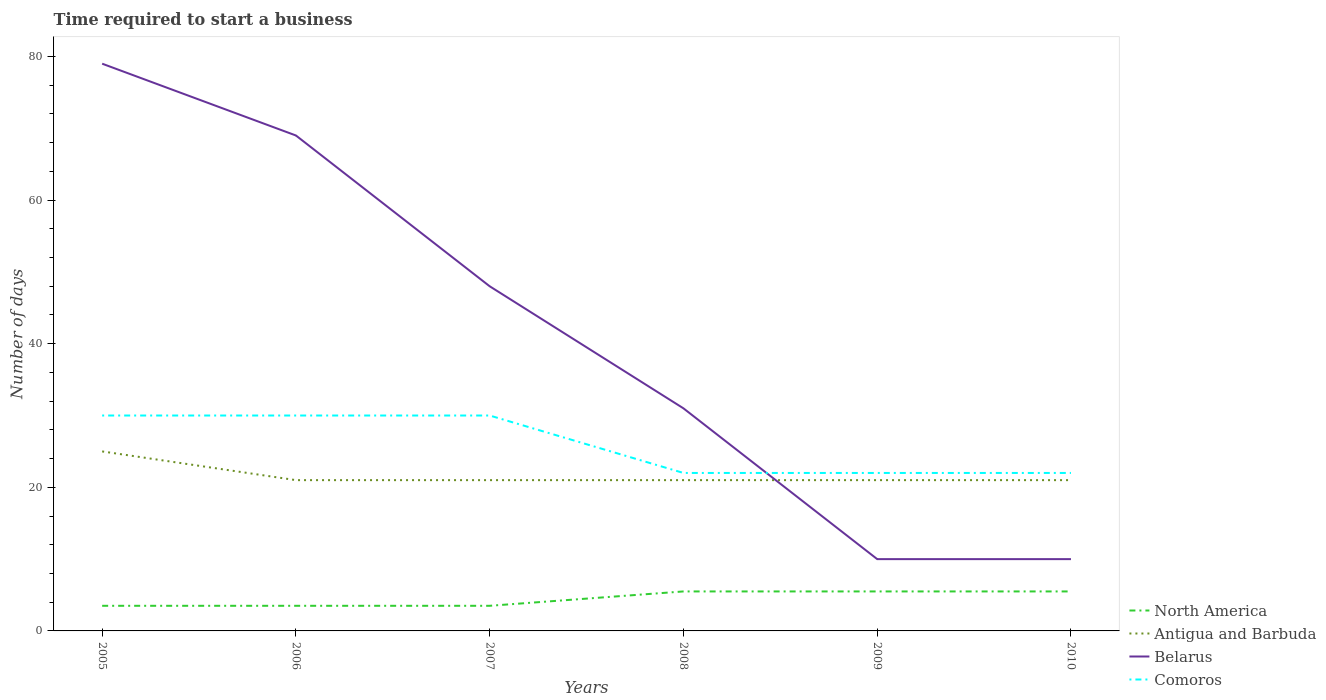Does the line corresponding to Comoros intersect with the line corresponding to North America?
Your answer should be compact. No. Is the number of lines equal to the number of legend labels?
Give a very brief answer. Yes. Across all years, what is the maximum number of days required to start a business in Antigua and Barbuda?
Your answer should be compact. 21. In which year was the number of days required to start a business in Antigua and Barbuda maximum?
Make the answer very short. 2006. What is the difference between the highest and the second highest number of days required to start a business in Antigua and Barbuda?
Give a very brief answer. 4. How many years are there in the graph?
Provide a short and direct response. 6. What is the difference between two consecutive major ticks on the Y-axis?
Provide a succinct answer. 20. Where does the legend appear in the graph?
Give a very brief answer. Bottom right. How many legend labels are there?
Your answer should be compact. 4. What is the title of the graph?
Ensure brevity in your answer.  Time required to start a business. Does "Syrian Arab Republic" appear as one of the legend labels in the graph?
Your answer should be compact. No. What is the label or title of the X-axis?
Provide a short and direct response. Years. What is the label or title of the Y-axis?
Keep it short and to the point. Number of days. What is the Number of days in Antigua and Barbuda in 2005?
Provide a short and direct response. 25. What is the Number of days in Belarus in 2005?
Give a very brief answer. 79. What is the Number of days in North America in 2006?
Offer a terse response. 3.5. What is the Number of days in Comoros in 2006?
Provide a short and direct response. 30. What is the Number of days of North America in 2007?
Your answer should be compact. 3.5. What is the Number of days of Antigua and Barbuda in 2007?
Offer a terse response. 21. What is the Number of days in Belarus in 2007?
Offer a terse response. 48. What is the Number of days in Comoros in 2007?
Ensure brevity in your answer.  30. What is the Number of days in Belarus in 2008?
Provide a short and direct response. 31. What is the Number of days of North America in 2009?
Offer a very short reply. 5.5. What is the Number of days in North America in 2010?
Offer a very short reply. 5.5. What is the Number of days of Antigua and Barbuda in 2010?
Provide a short and direct response. 21. What is the Number of days in Belarus in 2010?
Your response must be concise. 10. What is the Number of days in Comoros in 2010?
Provide a short and direct response. 22. Across all years, what is the maximum Number of days of North America?
Offer a terse response. 5.5. Across all years, what is the maximum Number of days in Antigua and Barbuda?
Keep it short and to the point. 25. Across all years, what is the maximum Number of days of Belarus?
Give a very brief answer. 79. Across all years, what is the maximum Number of days in Comoros?
Your answer should be very brief. 30. Across all years, what is the minimum Number of days of Comoros?
Give a very brief answer. 22. What is the total Number of days in North America in the graph?
Keep it short and to the point. 27. What is the total Number of days of Antigua and Barbuda in the graph?
Your answer should be compact. 130. What is the total Number of days of Belarus in the graph?
Keep it short and to the point. 247. What is the total Number of days of Comoros in the graph?
Give a very brief answer. 156. What is the difference between the Number of days in Belarus in 2005 and that in 2006?
Provide a succinct answer. 10. What is the difference between the Number of days in Comoros in 2005 and that in 2007?
Your answer should be very brief. 0. What is the difference between the Number of days of North America in 2005 and that in 2008?
Keep it short and to the point. -2. What is the difference between the Number of days of Antigua and Barbuda in 2005 and that in 2008?
Offer a terse response. 4. What is the difference between the Number of days in Comoros in 2005 and that in 2009?
Offer a terse response. 8. What is the difference between the Number of days in North America in 2005 and that in 2010?
Your response must be concise. -2. What is the difference between the Number of days in Antigua and Barbuda in 2005 and that in 2010?
Your answer should be compact. 4. What is the difference between the Number of days in Belarus in 2005 and that in 2010?
Provide a succinct answer. 69. What is the difference between the Number of days in North America in 2006 and that in 2007?
Give a very brief answer. 0. What is the difference between the Number of days in Antigua and Barbuda in 2006 and that in 2007?
Make the answer very short. 0. What is the difference between the Number of days of Comoros in 2006 and that in 2007?
Your answer should be very brief. 0. What is the difference between the Number of days in North America in 2006 and that in 2008?
Ensure brevity in your answer.  -2. What is the difference between the Number of days in Antigua and Barbuda in 2006 and that in 2009?
Ensure brevity in your answer.  0. What is the difference between the Number of days in Belarus in 2006 and that in 2009?
Keep it short and to the point. 59. What is the difference between the Number of days in Comoros in 2006 and that in 2009?
Provide a short and direct response. 8. What is the difference between the Number of days of Belarus in 2006 and that in 2010?
Ensure brevity in your answer.  59. What is the difference between the Number of days of Comoros in 2006 and that in 2010?
Ensure brevity in your answer.  8. What is the difference between the Number of days in Antigua and Barbuda in 2007 and that in 2008?
Keep it short and to the point. 0. What is the difference between the Number of days in Belarus in 2007 and that in 2008?
Provide a succinct answer. 17. What is the difference between the Number of days of North America in 2007 and that in 2009?
Provide a short and direct response. -2. What is the difference between the Number of days in Antigua and Barbuda in 2007 and that in 2009?
Give a very brief answer. 0. What is the difference between the Number of days of Belarus in 2007 and that in 2009?
Provide a short and direct response. 38. What is the difference between the Number of days of Comoros in 2007 and that in 2009?
Make the answer very short. 8. What is the difference between the Number of days of North America in 2008 and that in 2009?
Ensure brevity in your answer.  0. What is the difference between the Number of days of Belarus in 2008 and that in 2009?
Offer a very short reply. 21. What is the difference between the Number of days in Comoros in 2008 and that in 2009?
Keep it short and to the point. 0. What is the difference between the Number of days of North America in 2008 and that in 2010?
Your response must be concise. 0. What is the difference between the Number of days of North America in 2009 and that in 2010?
Provide a succinct answer. 0. What is the difference between the Number of days in Belarus in 2009 and that in 2010?
Keep it short and to the point. 0. What is the difference between the Number of days in North America in 2005 and the Number of days in Antigua and Barbuda in 2006?
Keep it short and to the point. -17.5. What is the difference between the Number of days in North America in 2005 and the Number of days in Belarus in 2006?
Your answer should be very brief. -65.5. What is the difference between the Number of days of North America in 2005 and the Number of days of Comoros in 2006?
Keep it short and to the point. -26.5. What is the difference between the Number of days in Antigua and Barbuda in 2005 and the Number of days in Belarus in 2006?
Provide a succinct answer. -44. What is the difference between the Number of days in North America in 2005 and the Number of days in Antigua and Barbuda in 2007?
Offer a very short reply. -17.5. What is the difference between the Number of days in North America in 2005 and the Number of days in Belarus in 2007?
Give a very brief answer. -44.5. What is the difference between the Number of days in North America in 2005 and the Number of days in Comoros in 2007?
Keep it short and to the point. -26.5. What is the difference between the Number of days in Antigua and Barbuda in 2005 and the Number of days in Belarus in 2007?
Provide a short and direct response. -23. What is the difference between the Number of days of Antigua and Barbuda in 2005 and the Number of days of Comoros in 2007?
Offer a very short reply. -5. What is the difference between the Number of days of Belarus in 2005 and the Number of days of Comoros in 2007?
Give a very brief answer. 49. What is the difference between the Number of days of North America in 2005 and the Number of days of Antigua and Barbuda in 2008?
Make the answer very short. -17.5. What is the difference between the Number of days in North America in 2005 and the Number of days in Belarus in 2008?
Ensure brevity in your answer.  -27.5. What is the difference between the Number of days in North America in 2005 and the Number of days in Comoros in 2008?
Give a very brief answer. -18.5. What is the difference between the Number of days of Antigua and Barbuda in 2005 and the Number of days of Comoros in 2008?
Your answer should be very brief. 3. What is the difference between the Number of days in Belarus in 2005 and the Number of days in Comoros in 2008?
Provide a succinct answer. 57. What is the difference between the Number of days of North America in 2005 and the Number of days of Antigua and Barbuda in 2009?
Your answer should be very brief. -17.5. What is the difference between the Number of days of North America in 2005 and the Number of days of Comoros in 2009?
Offer a very short reply. -18.5. What is the difference between the Number of days of North America in 2005 and the Number of days of Antigua and Barbuda in 2010?
Offer a very short reply. -17.5. What is the difference between the Number of days in North America in 2005 and the Number of days in Belarus in 2010?
Provide a succinct answer. -6.5. What is the difference between the Number of days of North America in 2005 and the Number of days of Comoros in 2010?
Provide a succinct answer. -18.5. What is the difference between the Number of days in Antigua and Barbuda in 2005 and the Number of days in Belarus in 2010?
Your response must be concise. 15. What is the difference between the Number of days of Antigua and Barbuda in 2005 and the Number of days of Comoros in 2010?
Give a very brief answer. 3. What is the difference between the Number of days of Belarus in 2005 and the Number of days of Comoros in 2010?
Provide a succinct answer. 57. What is the difference between the Number of days in North America in 2006 and the Number of days in Antigua and Barbuda in 2007?
Your answer should be compact. -17.5. What is the difference between the Number of days of North America in 2006 and the Number of days of Belarus in 2007?
Make the answer very short. -44.5. What is the difference between the Number of days of North America in 2006 and the Number of days of Comoros in 2007?
Provide a succinct answer. -26.5. What is the difference between the Number of days in North America in 2006 and the Number of days in Antigua and Barbuda in 2008?
Make the answer very short. -17.5. What is the difference between the Number of days in North America in 2006 and the Number of days in Belarus in 2008?
Give a very brief answer. -27.5. What is the difference between the Number of days of North America in 2006 and the Number of days of Comoros in 2008?
Keep it short and to the point. -18.5. What is the difference between the Number of days in Antigua and Barbuda in 2006 and the Number of days in Comoros in 2008?
Your answer should be compact. -1. What is the difference between the Number of days in Belarus in 2006 and the Number of days in Comoros in 2008?
Your answer should be very brief. 47. What is the difference between the Number of days in North America in 2006 and the Number of days in Antigua and Barbuda in 2009?
Keep it short and to the point. -17.5. What is the difference between the Number of days in North America in 2006 and the Number of days in Comoros in 2009?
Offer a very short reply. -18.5. What is the difference between the Number of days of Antigua and Barbuda in 2006 and the Number of days of Belarus in 2009?
Offer a very short reply. 11. What is the difference between the Number of days of Antigua and Barbuda in 2006 and the Number of days of Comoros in 2009?
Make the answer very short. -1. What is the difference between the Number of days in North America in 2006 and the Number of days in Antigua and Barbuda in 2010?
Keep it short and to the point. -17.5. What is the difference between the Number of days of North America in 2006 and the Number of days of Comoros in 2010?
Your answer should be very brief. -18.5. What is the difference between the Number of days in North America in 2007 and the Number of days in Antigua and Barbuda in 2008?
Make the answer very short. -17.5. What is the difference between the Number of days in North America in 2007 and the Number of days in Belarus in 2008?
Provide a short and direct response. -27.5. What is the difference between the Number of days in North America in 2007 and the Number of days in Comoros in 2008?
Ensure brevity in your answer.  -18.5. What is the difference between the Number of days in Antigua and Barbuda in 2007 and the Number of days in Belarus in 2008?
Offer a very short reply. -10. What is the difference between the Number of days in Belarus in 2007 and the Number of days in Comoros in 2008?
Your answer should be compact. 26. What is the difference between the Number of days of North America in 2007 and the Number of days of Antigua and Barbuda in 2009?
Offer a terse response. -17.5. What is the difference between the Number of days in North America in 2007 and the Number of days in Belarus in 2009?
Your response must be concise. -6.5. What is the difference between the Number of days in North America in 2007 and the Number of days in Comoros in 2009?
Offer a very short reply. -18.5. What is the difference between the Number of days of Antigua and Barbuda in 2007 and the Number of days of Belarus in 2009?
Ensure brevity in your answer.  11. What is the difference between the Number of days in North America in 2007 and the Number of days in Antigua and Barbuda in 2010?
Ensure brevity in your answer.  -17.5. What is the difference between the Number of days in North America in 2007 and the Number of days in Belarus in 2010?
Provide a short and direct response. -6.5. What is the difference between the Number of days of North America in 2007 and the Number of days of Comoros in 2010?
Offer a very short reply. -18.5. What is the difference between the Number of days in Antigua and Barbuda in 2007 and the Number of days in Belarus in 2010?
Offer a very short reply. 11. What is the difference between the Number of days of Antigua and Barbuda in 2007 and the Number of days of Comoros in 2010?
Your response must be concise. -1. What is the difference between the Number of days of North America in 2008 and the Number of days of Antigua and Barbuda in 2009?
Provide a short and direct response. -15.5. What is the difference between the Number of days of North America in 2008 and the Number of days of Comoros in 2009?
Offer a terse response. -16.5. What is the difference between the Number of days in Antigua and Barbuda in 2008 and the Number of days in Belarus in 2009?
Provide a succinct answer. 11. What is the difference between the Number of days in Belarus in 2008 and the Number of days in Comoros in 2009?
Offer a terse response. 9. What is the difference between the Number of days of North America in 2008 and the Number of days of Antigua and Barbuda in 2010?
Provide a succinct answer. -15.5. What is the difference between the Number of days of North America in 2008 and the Number of days of Comoros in 2010?
Give a very brief answer. -16.5. What is the difference between the Number of days of Antigua and Barbuda in 2008 and the Number of days of Comoros in 2010?
Give a very brief answer. -1. What is the difference between the Number of days of North America in 2009 and the Number of days of Antigua and Barbuda in 2010?
Ensure brevity in your answer.  -15.5. What is the difference between the Number of days of North America in 2009 and the Number of days of Belarus in 2010?
Provide a short and direct response. -4.5. What is the difference between the Number of days in North America in 2009 and the Number of days in Comoros in 2010?
Your answer should be very brief. -16.5. What is the difference between the Number of days in Antigua and Barbuda in 2009 and the Number of days in Belarus in 2010?
Your answer should be compact. 11. What is the average Number of days of North America per year?
Give a very brief answer. 4.5. What is the average Number of days of Antigua and Barbuda per year?
Your answer should be very brief. 21.67. What is the average Number of days in Belarus per year?
Your answer should be compact. 41.17. What is the average Number of days in Comoros per year?
Keep it short and to the point. 26. In the year 2005, what is the difference between the Number of days of North America and Number of days of Antigua and Barbuda?
Offer a terse response. -21.5. In the year 2005, what is the difference between the Number of days in North America and Number of days in Belarus?
Give a very brief answer. -75.5. In the year 2005, what is the difference between the Number of days of North America and Number of days of Comoros?
Ensure brevity in your answer.  -26.5. In the year 2005, what is the difference between the Number of days of Antigua and Barbuda and Number of days of Belarus?
Give a very brief answer. -54. In the year 2005, what is the difference between the Number of days of Belarus and Number of days of Comoros?
Ensure brevity in your answer.  49. In the year 2006, what is the difference between the Number of days in North America and Number of days in Antigua and Barbuda?
Your answer should be very brief. -17.5. In the year 2006, what is the difference between the Number of days of North America and Number of days of Belarus?
Give a very brief answer. -65.5. In the year 2006, what is the difference between the Number of days of North America and Number of days of Comoros?
Make the answer very short. -26.5. In the year 2006, what is the difference between the Number of days in Antigua and Barbuda and Number of days in Belarus?
Keep it short and to the point. -48. In the year 2006, what is the difference between the Number of days of Antigua and Barbuda and Number of days of Comoros?
Provide a succinct answer. -9. In the year 2007, what is the difference between the Number of days of North America and Number of days of Antigua and Barbuda?
Provide a succinct answer. -17.5. In the year 2007, what is the difference between the Number of days of North America and Number of days of Belarus?
Give a very brief answer. -44.5. In the year 2007, what is the difference between the Number of days in North America and Number of days in Comoros?
Make the answer very short. -26.5. In the year 2007, what is the difference between the Number of days in Antigua and Barbuda and Number of days in Comoros?
Your answer should be very brief. -9. In the year 2007, what is the difference between the Number of days in Belarus and Number of days in Comoros?
Your answer should be compact. 18. In the year 2008, what is the difference between the Number of days of North America and Number of days of Antigua and Barbuda?
Keep it short and to the point. -15.5. In the year 2008, what is the difference between the Number of days in North America and Number of days in Belarus?
Your answer should be very brief. -25.5. In the year 2008, what is the difference between the Number of days of North America and Number of days of Comoros?
Ensure brevity in your answer.  -16.5. In the year 2008, what is the difference between the Number of days in Antigua and Barbuda and Number of days in Comoros?
Provide a succinct answer. -1. In the year 2009, what is the difference between the Number of days of North America and Number of days of Antigua and Barbuda?
Make the answer very short. -15.5. In the year 2009, what is the difference between the Number of days in North America and Number of days in Comoros?
Offer a terse response. -16.5. In the year 2009, what is the difference between the Number of days of Antigua and Barbuda and Number of days of Belarus?
Offer a terse response. 11. In the year 2010, what is the difference between the Number of days of North America and Number of days of Antigua and Barbuda?
Your response must be concise. -15.5. In the year 2010, what is the difference between the Number of days in North America and Number of days in Comoros?
Your answer should be compact. -16.5. In the year 2010, what is the difference between the Number of days of Belarus and Number of days of Comoros?
Offer a terse response. -12. What is the ratio of the Number of days of North America in 2005 to that in 2006?
Make the answer very short. 1. What is the ratio of the Number of days of Antigua and Barbuda in 2005 to that in 2006?
Offer a very short reply. 1.19. What is the ratio of the Number of days of Belarus in 2005 to that in 2006?
Your answer should be compact. 1.14. What is the ratio of the Number of days in Comoros in 2005 to that in 2006?
Provide a succinct answer. 1. What is the ratio of the Number of days of North America in 2005 to that in 2007?
Your response must be concise. 1. What is the ratio of the Number of days of Antigua and Barbuda in 2005 to that in 2007?
Ensure brevity in your answer.  1.19. What is the ratio of the Number of days of Belarus in 2005 to that in 2007?
Ensure brevity in your answer.  1.65. What is the ratio of the Number of days of Comoros in 2005 to that in 2007?
Offer a terse response. 1. What is the ratio of the Number of days of North America in 2005 to that in 2008?
Your answer should be compact. 0.64. What is the ratio of the Number of days of Antigua and Barbuda in 2005 to that in 2008?
Keep it short and to the point. 1.19. What is the ratio of the Number of days of Belarus in 2005 to that in 2008?
Your answer should be very brief. 2.55. What is the ratio of the Number of days in Comoros in 2005 to that in 2008?
Give a very brief answer. 1.36. What is the ratio of the Number of days of North America in 2005 to that in 2009?
Keep it short and to the point. 0.64. What is the ratio of the Number of days of Antigua and Barbuda in 2005 to that in 2009?
Offer a very short reply. 1.19. What is the ratio of the Number of days in Comoros in 2005 to that in 2009?
Offer a very short reply. 1.36. What is the ratio of the Number of days in North America in 2005 to that in 2010?
Offer a terse response. 0.64. What is the ratio of the Number of days of Antigua and Barbuda in 2005 to that in 2010?
Make the answer very short. 1.19. What is the ratio of the Number of days of Belarus in 2005 to that in 2010?
Offer a very short reply. 7.9. What is the ratio of the Number of days in Comoros in 2005 to that in 2010?
Offer a terse response. 1.36. What is the ratio of the Number of days of Belarus in 2006 to that in 2007?
Offer a very short reply. 1.44. What is the ratio of the Number of days of Comoros in 2006 to that in 2007?
Offer a very short reply. 1. What is the ratio of the Number of days of North America in 2006 to that in 2008?
Offer a very short reply. 0.64. What is the ratio of the Number of days in Antigua and Barbuda in 2006 to that in 2008?
Keep it short and to the point. 1. What is the ratio of the Number of days of Belarus in 2006 to that in 2008?
Your answer should be compact. 2.23. What is the ratio of the Number of days of Comoros in 2006 to that in 2008?
Offer a terse response. 1.36. What is the ratio of the Number of days of North America in 2006 to that in 2009?
Give a very brief answer. 0.64. What is the ratio of the Number of days in Antigua and Barbuda in 2006 to that in 2009?
Keep it short and to the point. 1. What is the ratio of the Number of days of Belarus in 2006 to that in 2009?
Offer a very short reply. 6.9. What is the ratio of the Number of days of Comoros in 2006 to that in 2009?
Your response must be concise. 1.36. What is the ratio of the Number of days in North America in 2006 to that in 2010?
Offer a very short reply. 0.64. What is the ratio of the Number of days of Antigua and Barbuda in 2006 to that in 2010?
Provide a succinct answer. 1. What is the ratio of the Number of days in Comoros in 2006 to that in 2010?
Provide a succinct answer. 1.36. What is the ratio of the Number of days in North America in 2007 to that in 2008?
Your answer should be very brief. 0.64. What is the ratio of the Number of days in Antigua and Barbuda in 2007 to that in 2008?
Offer a very short reply. 1. What is the ratio of the Number of days of Belarus in 2007 to that in 2008?
Give a very brief answer. 1.55. What is the ratio of the Number of days of Comoros in 2007 to that in 2008?
Ensure brevity in your answer.  1.36. What is the ratio of the Number of days of North America in 2007 to that in 2009?
Keep it short and to the point. 0.64. What is the ratio of the Number of days of Antigua and Barbuda in 2007 to that in 2009?
Keep it short and to the point. 1. What is the ratio of the Number of days in Belarus in 2007 to that in 2009?
Your answer should be compact. 4.8. What is the ratio of the Number of days in Comoros in 2007 to that in 2009?
Offer a very short reply. 1.36. What is the ratio of the Number of days of North America in 2007 to that in 2010?
Provide a succinct answer. 0.64. What is the ratio of the Number of days in Belarus in 2007 to that in 2010?
Make the answer very short. 4.8. What is the ratio of the Number of days in Comoros in 2007 to that in 2010?
Make the answer very short. 1.36. What is the ratio of the Number of days in North America in 2008 to that in 2009?
Provide a succinct answer. 1. What is the ratio of the Number of days in North America in 2009 to that in 2010?
Ensure brevity in your answer.  1. What is the ratio of the Number of days of Antigua and Barbuda in 2009 to that in 2010?
Keep it short and to the point. 1. What is the ratio of the Number of days in Belarus in 2009 to that in 2010?
Offer a very short reply. 1. What is the difference between the highest and the second highest Number of days in North America?
Offer a very short reply. 0. What is the difference between the highest and the second highest Number of days in Belarus?
Give a very brief answer. 10. What is the difference between the highest and the lowest Number of days in Antigua and Barbuda?
Provide a short and direct response. 4. What is the difference between the highest and the lowest Number of days in Belarus?
Provide a short and direct response. 69. 